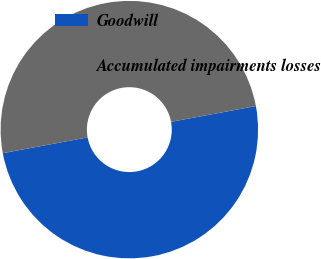Convert chart to OTSL. <chart><loc_0><loc_0><loc_500><loc_500><pie_chart><fcel>Goodwill<fcel>Accumulated impairments losses<nl><fcel>50.0%<fcel>50.0%<nl></chart> 